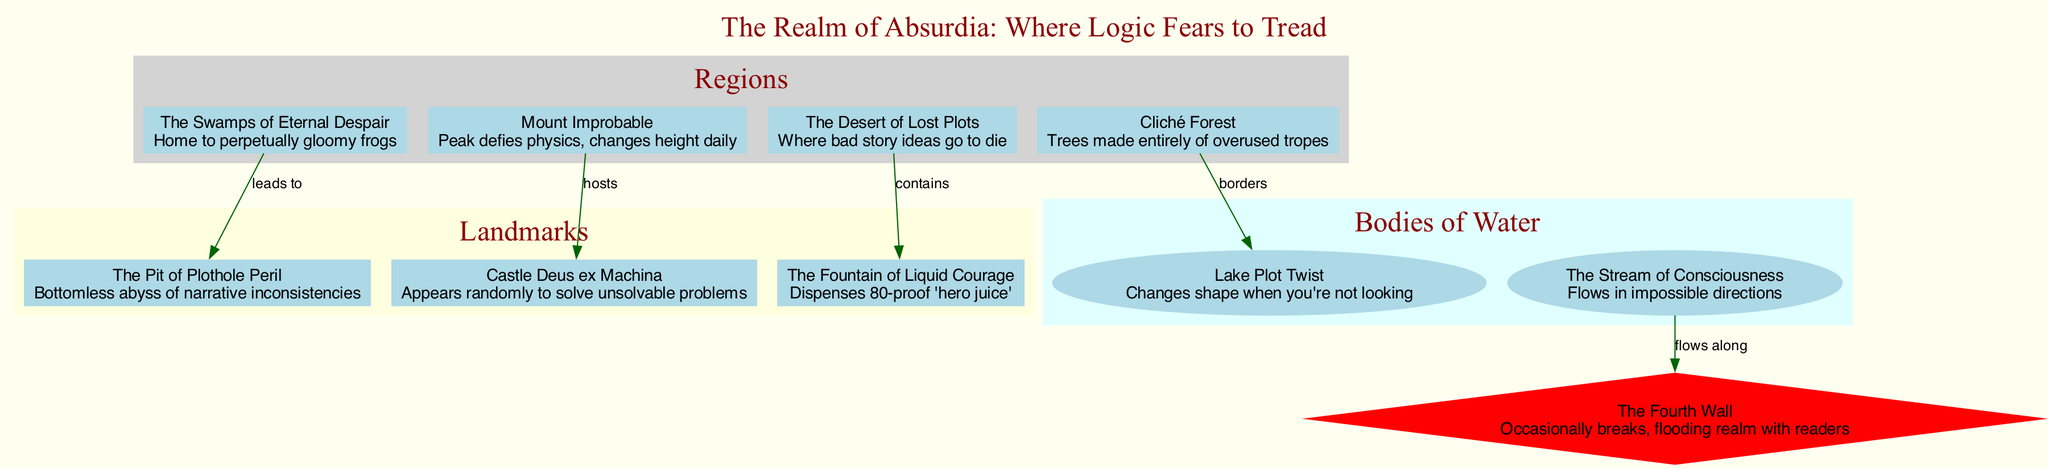What is the name of the region that is home to perpetually gloomy frogs? The diagram labels the region home to perpetually gloomy frogs as "The Swamps of Eternal Despair". I directly reference the region's name from the provided details.
Answer: The Swamps of Eternal Despair How many landmarks are there in the Realm of Absurdia? By counting the entries in the landmarks section of the diagram, I see there are three distinct landmarks: The Pit of Plothole Peril, Castle Deus ex Machina, and The Fountain of Liquid Courage.
Answer: 3 What flows along the Fourth Wall? The diagram shows an edge connecting "The Stream of Consciousness" to "The Fourth Wall", indicating that the stream flows along this border.
Answer: The Stream of Consciousness Which region contains the Fountain of Liquid Courage? Looking at the relationships in the diagram, the edge specifies that the Desert of Lost Plots contains the Fountain of Liquid Courage. I directly reference this connection.
Answer: The Desert of Lost Plots What type of tree is found in Cliché Forest? The description of Cliché Forest in the diagram states that it contains trees made entirely of overused tropes, which is a direct quote from the information provided.
Answer: Overused tropes Which landmark randomly appears to solve unsolvable problems? The diagram points out that "Castle Deus ex Machina" is the landmark that randomly appears to resolve unsolvable issues. This title is explicitly mentioned in the landmark details.
Answer: Castle Deus ex Machina What can be found at the bottom of The Pit of Plothole Peril? According to the diagram, The Pit of Plothole Peril is described as a bottomless abyss of narrative inconsistencies, providing a specific answer to the question.
Answer: Narrative inconsistencies Which body of water changes shape when you're not looking? From the body of water section in the diagram, "Lake Plot Twist" is specifically stated to change shape when not observed, making it the clear answer.
Answer: Lake Plot Twist What is the color of the regions in the diagram? The regions are shown in light grey in the diagram, as depicted in the subgraph section labeled 'Regions,' which provides the color information directly.
Answer: Light grey 